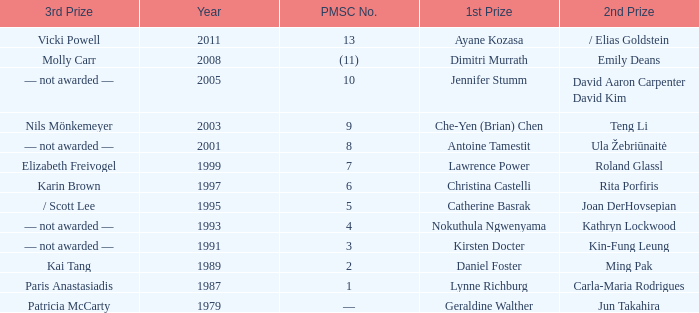What is the earliest year in which the 1st price went to Che-Yen (Brian) Chen? 2003.0. Could you parse the entire table as a dict? {'header': ['3rd Prize', 'Year', 'PMSC No.', '1st Prize', '2nd Prize'], 'rows': [['Vicki Powell', '2011', '13', 'Ayane Kozasa', '/ Elias Goldstein'], ['Molly Carr', '2008', '(11)', 'Dimitri Murrath', 'Emily Deans'], ['— not awarded —', '2005', '10', 'Jennifer Stumm', 'David Aaron Carpenter David Kim'], ['Nils Mönkemeyer', '2003', '9', 'Che-Yen (Brian) Chen', 'Teng Li'], ['— not awarded —', '2001', '8', 'Antoine Tamestit', 'Ula Žebriūnaitė'], ['Elizabeth Freivogel', '1999', '7', 'Lawrence Power', 'Roland Glassl'], ['Karin Brown', '1997', '6', 'Christina Castelli', 'Rita Porfiris'], ['/ Scott Lee', '1995', '5', 'Catherine Basrak', 'Joan DerHovsepian'], ['— not awarded —', '1993', '4', 'Nokuthula Ngwenyama', 'Kathryn Lockwood'], ['— not awarded —', '1991', '3', 'Kirsten Docter', 'Kin-Fung Leung'], ['Kai Tang', '1989', '2', 'Daniel Foster', 'Ming Pak'], ['Paris Anastasiadis', '1987', '1', 'Lynne Richburg', 'Carla-Maria Rodrigues'], ['Patricia McCarty', '1979', '—', 'Geraldine Walther', 'Jun Takahira']]} 